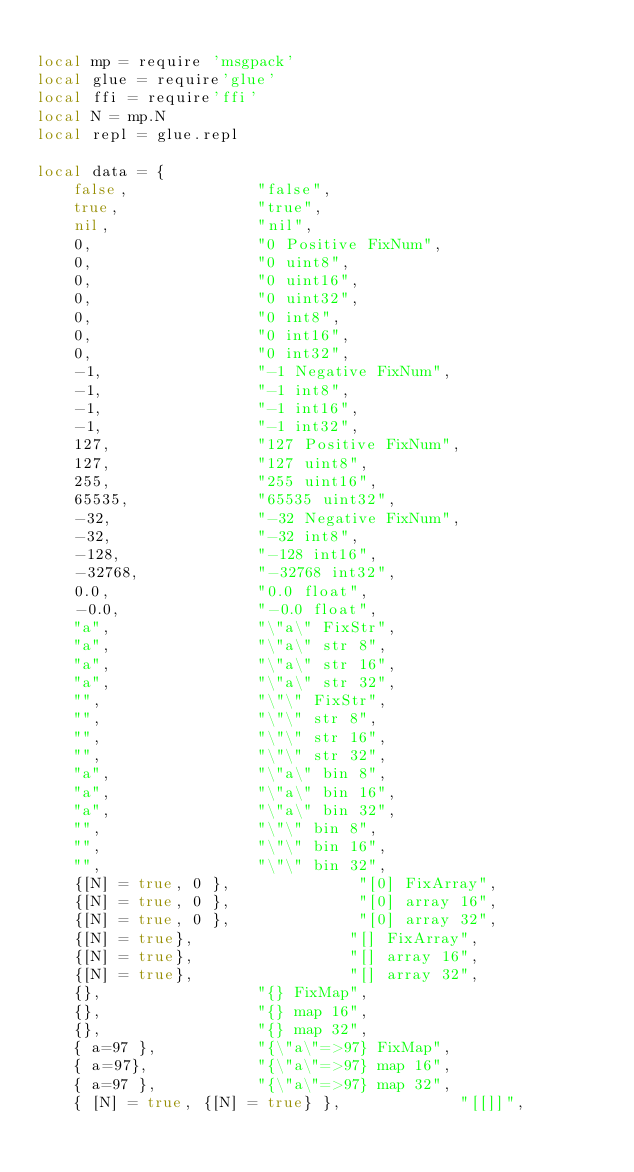<code> <loc_0><loc_0><loc_500><loc_500><_Lua_>
local mp = require 'msgpack'
local glue = require'glue'
local ffi = require'ffi'
local N = mp.N
local repl = glue.repl

local data = {
    false,              "false",
    true,               "true",
    nil,                "nil",
    0,                  "0 Positive FixNum",
    0,                  "0 uint8",
    0,                  "0 uint16",
    0,                  "0 uint32",
    0,                  "0 int8",
    0,                  "0 int16",
    0,                  "0 int32",
    -1,                 "-1 Negative FixNum",
    -1,                 "-1 int8",
    -1,                 "-1 int16",
    -1,                 "-1 int32",
    127,                "127 Positive FixNum",
    127,                "127 uint8",
    255,                "255 uint16",
    65535,              "65535 uint32",
    -32,                "-32 Negative FixNum",
    -32,                "-32 int8",
    -128,               "-128 int16",
    -32768,             "-32768 int32",
    0.0,                "0.0 float",
    -0.0,               "-0.0 float",
    "a",                "\"a\" FixStr",
    "a",                "\"a\" str 8",
    "a",                "\"a\" str 16",
    "a",                "\"a\" str 32",
    "",                 "\"\" FixStr",
    "",                 "\"\" str 8",
    "",                 "\"\" str 16",
    "",                 "\"\" str 32",
    "a",                "\"a\" bin 8",
    "a",                "\"a\" bin 16",
    "a",                "\"a\" bin 32",
    "",                 "\"\" bin 8",
    "",                 "\"\" bin 16",
    "",                 "\"\" bin 32",
    {[N] = true, 0 },              "[0] FixArray",
    {[N] = true, 0 },              "[0] array 16",
    {[N] = true, 0 },              "[0] array 32",
    {[N] = true},                 "[] FixArray",
    {[N] = true},                 "[] array 16",
    {[N] = true},                 "[] array 32",
    {},                 "{} FixMap",
    {},                 "{} map 16",
    {},                 "{} map 32",
    { a=97 },           "{\"a\"=>97} FixMap",
    { a=97},            "{\"a\"=>97} map 16",
    { a=97 },           "{\"a\"=>97} map 32",
    { [N] = true, {[N] = true} },             "[[]]",</code> 